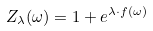<formula> <loc_0><loc_0><loc_500><loc_500>Z _ { \lambda } ( \omega ) = 1 + e ^ { \lambda \cdot f ( \omega ) }</formula> 